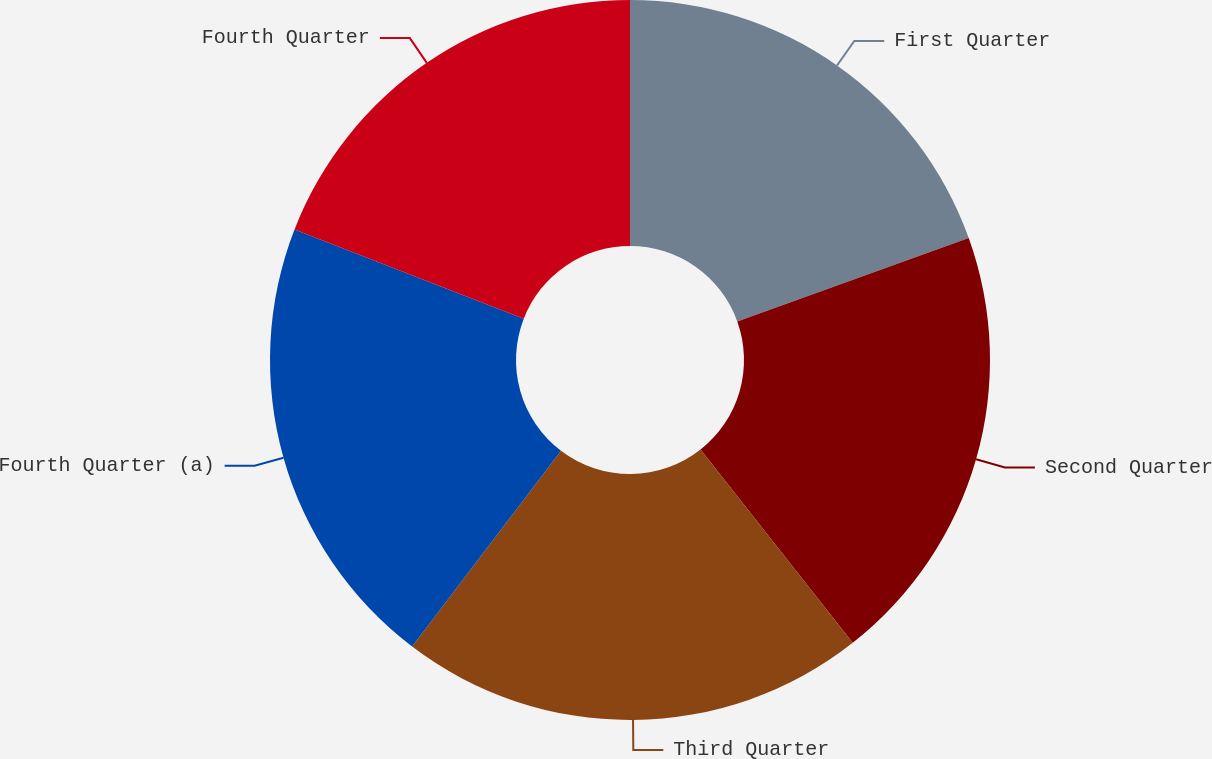<chart> <loc_0><loc_0><loc_500><loc_500><pie_chart><fcel>First Quarter<fcel>Second Quarter<fcel>Third Quarter<fcel>Fourth Quarter (a)<fcel>Fourth Quarter<nl><fcel>19.5%<fcel>19.88%<fcel>20.96%<fcel>20.56%<fcel>19.09%<nl></chart> 